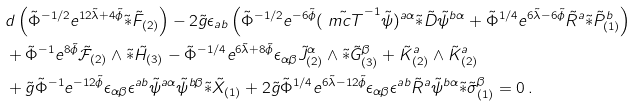Convert formula to latex. <formula><loc_0><loc_0><loc_500><loc_500>& d \left ( \tilde { \Phi } ^ { - 1 / 2 } e ^ { 1 2 \tilde { \lambda } + 4 \tilde { \phi } } \tilde { \ast } \tilde { F } _ { ( 2 ) } \right ) - 2 \tilde { g } \epsilon _ { a b } \left ( \tilde { \Phi } ^ { - 1 / 2 } e ^ { - 6 \tilde { \phi } } ( \tilde { \ m c { T } } ^ { - 1 } \tilde { \psi } ) ^ { a \alpha } { \tilde { \ast } \tilde { D } \tilde { \psi } ^ { b \alpha } } + \tilde { \Phi } ^ { 1 / 4 } e ^ { 6 \tilde { \lambda } - 6 \tilde { \phi } } \tilde { R } ^ { a } { \tilde { \ast } \tilde { P } ^ { b } _ { ( 1 ) } } \right ) \\ & + \tilde { \Phi } ^ { - 1 } e ^ { 8 \tilde { \phi } } \tilde { \mathcal { F } } _ { ( 2 ) } \wedge { \tilde { \ast } \tilde { H } _ { ( 3 ) } } - \tilde { \Phi } ^ { - 1 / 4 } e ^ { 6 \tilde { \lambda } + 8 \tilde { \phi } } \epsilon _ { \alpha \beta } \tilde { J } ^ { \alpha } _ { ( 2 ) } \wedge { \tilde { \ast } \tilde { G } ^ { \beta } _ { ( 3 ) } } + \tilde { K } ^ { a } _ { ( 2 ) } \wedge \tilde { K } ^ { a } _ { ( 2 ) } \\ & + \tilde { g } \tilde { \Phi } ^ { - 1 } e ^ { - 1 2 \tilde { \phi } } \epsilon _ { \alpha \beta } \epsilon ^ { a b } \tilde { \psi } ^ { a \alpha } \tilde { \psi } ^ { b \beta } { \tilde { \ast } \tilde { X } _ { ( 1 ) } } + 2 \tilde { g } \tilde { \Phi } ^ { 1 / 4 } e ^ { 6 \tilde { \lambda } - 1 2 \tilde { \phi } } \epsilon _ { \alpha \beta } \epsilon ^ { a b } \tilde { R } ^ { a } \tilde { \psi } ^ { b \alpha } { \tilde { \ast } \tilde { \sigma } ^ { \beta } _ { ( 1 ) } } = 0 \, .</formula> 